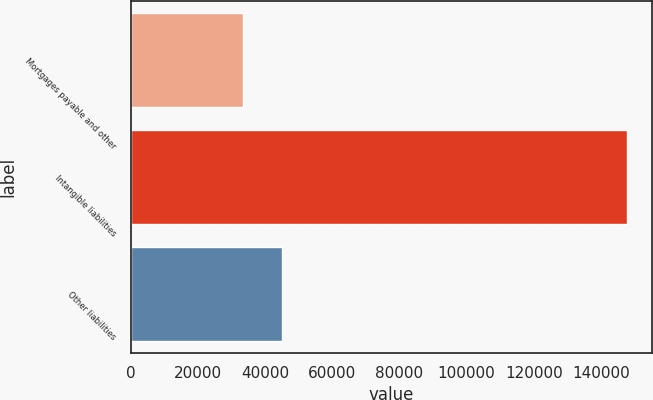Convert chart. <chart><loc_0><loc_0><loc_500><loc_500><bar_chart><fcel>Mortgages payable and other<fcel>Intangible liabilities<fcel>Other liabilities<nl><fcel>33553<fcel>147700<fcel>44967.7<nl></chart> 